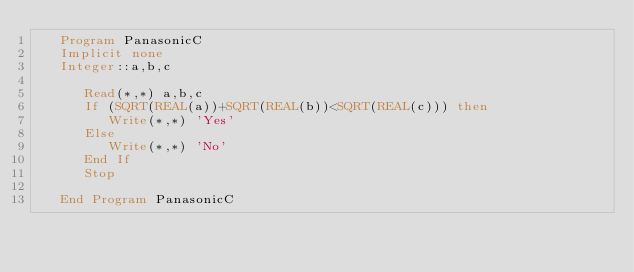<code> <loc_0><loc_0><loc_500><loc_500><_FORTRAN_>   Program PanasonicC
   Implicit none
   Integer::a,b,c

      Read(*,*) a,b,c
      If (SQRT(REAL(a))+SQRT(REAL(b))<SQRT(REAL(c))) then
         Write(*,*) 'Yes'
      Else
         Write(*,*) 'No'
      End If
      Stop

   End Program PanasonicC</code> 